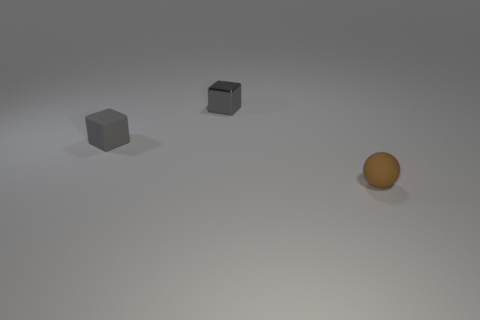Is there any other thing that has the same shape as the brown thing?
Make the answer very short. No. What is the color of the cube that is left of the shiny block?
Give a very brief answer. Gray. There is a object that is in front of the small shiny block and behind the brown sphere; what shape is it?
Your response must be concise. Cube. What number of small gray rubber objects have the same shape as the shiny thing?
Make the answer very short. 1. How many tiny matte things are there?
Ensure brevity in your answer.  2. There is a thing that is both in front of the small metallic thing and left of the small sphere; what size is it?
Offer a very short reply. Small. There is a metal object that is the same size as the brown matte sphere; what is its shape?
Make the answer very short. Cube. Are there any small brown spheres that are in front of the small matte thing that is behind the small brown rubber thing?
Your response must be concise. Yes. What is the color of the small metal object that is the same shape as the small gray matte object?
Offer a terse response. Gray. Do the small block on the left side of the small gray metallic cube and the small metal block have the same color?
Offer a very short reply. Yes. 